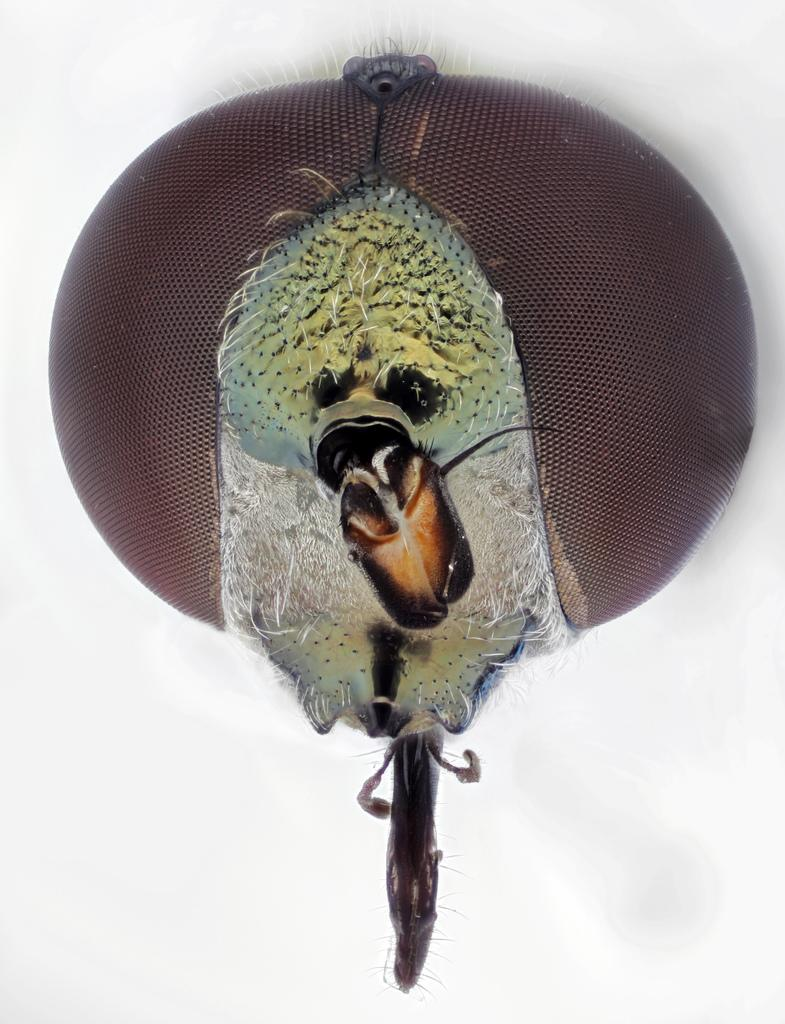What type of creature can be seen in the image? There is an insect in the image. What color is the background of the image? The background of the image is white. What type of plantation is visible in the image? There is no plantation present in the image; it features an insect and a white background. What cast members can be seen in the image? There are no cast members present in the image; it features an insect and a white background. 